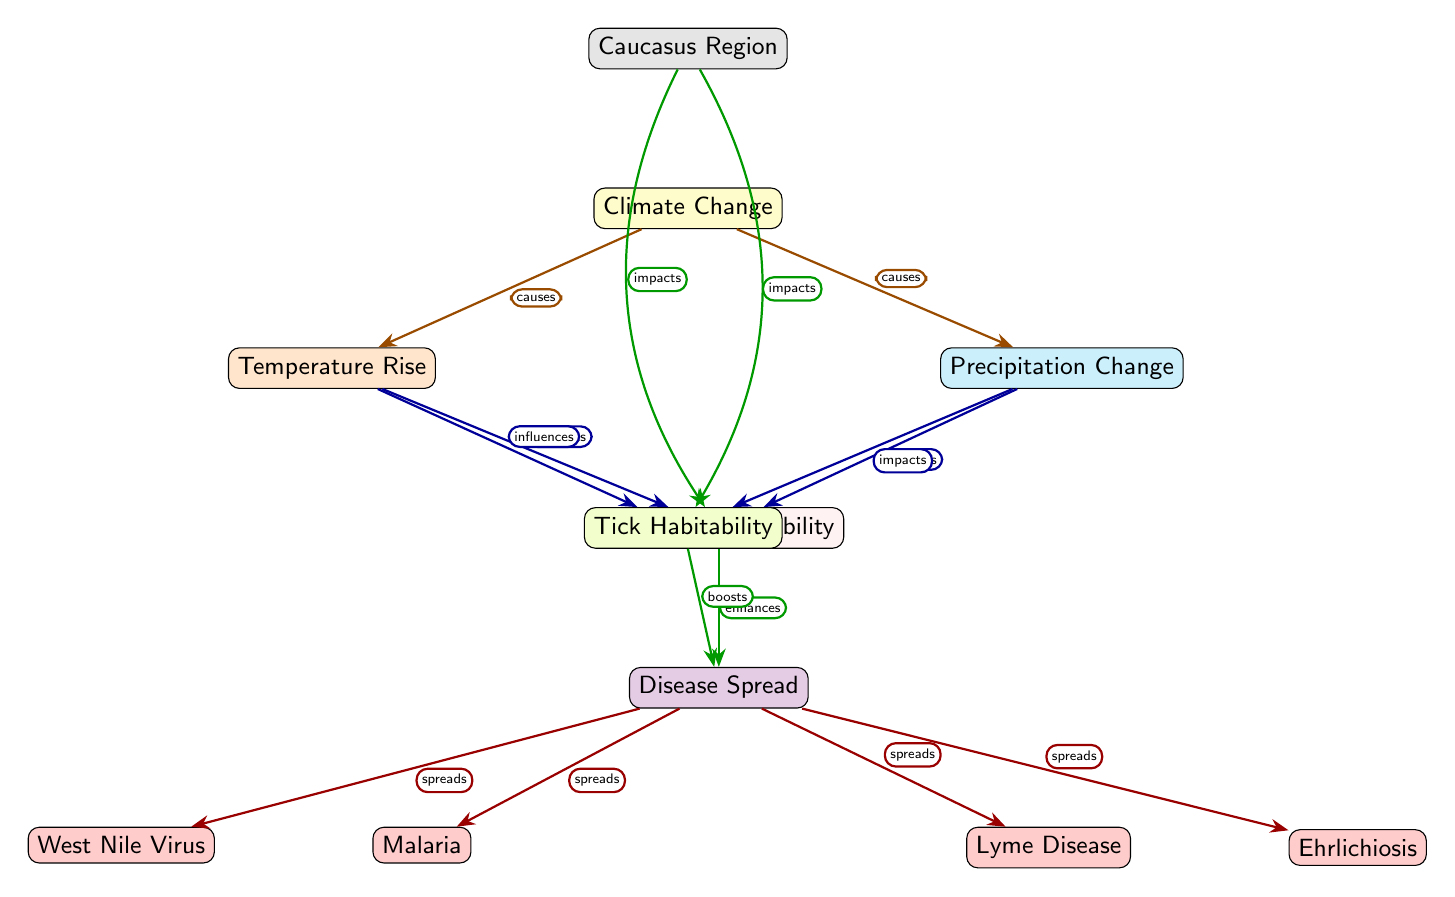What is the central node in the diagram? The central node represents the primary focus, which is "Climate Change." It is positioned centrally and connects to various other nodes indicating its influence.
Answer: Climate Change How many disease types are indicated in the diagram? There are four disease types displayed: Malaria, West Nile Virus, Lyme Disease, and Ehrlichiosis. By counting each labeled node under "Disease Spread," the total is four.
Answer: 4 Which two factors lead to increased mosquito habitability? The two factors are "Temperature Rise" and "Precipitation Change." Both are shown as sources of influence on the mosquito habitability node.
Answer: Temperature Rise and Precipitation Change What is the relationship between tick habitability and disease spread? The relationship is that tick habitability boosts disease spread. This is conveyed through the edge labeled "boosts" connecting "Tick Habitability" to "Disease Spread."
Answer: boosts How does the Caucasus region impact mosquito and tick habitability? The Caucasus region impacts both mosquito and tick habitability by influencing them. The diagram shows edges indicating that the region affects both habitability nodes.
Answer: impacts What type of arrow connects "Precipitation Change" to "Mosquito Habitability"? The diagram uses an "affects" labeled arrow to indicate the connection from "Precipitation Change" to "Mosquito Habitability," suggesting a direct influence.
Answer: affects Which disease is spread directly linked to both habitat types? Both Malaria and Lyme Disease are linked to the spread via the "Disease Spread" node, showing that these diseases are influenced by both mosquito and tick habitats.
Answer: Malaria and Lyme Disease What color represents the impact of "Climate Change" on "Tick Habitability"? The color representing this impact is gray, as it is used to denote the Caucasus region's effect on the tick habitability node.
Answer: gray 